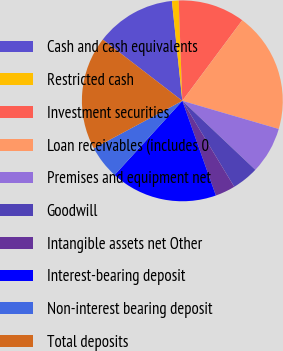Convert chart to OTSL. <chart><loc_0><loc_0><loc_500><loc_500><pie_chart><fcel>Cash and cash equivalents<fcel>Restricted cash<fcel>Investment securities<fcel>Loan receivables (includes 0<fcel>Premises and equipment net<fcel>Goodwill<fcel>Intangible assets net Other<fcel>Interest-bearing deposit<fcel>Non-interest bearing deposit<fcel>Total deposits<nl><fcel>12.9%<fcel>1.08%<fcel>10.75%<fcel>19.35%<fcel>7.53%<fcel>4.3%<fcel>3.23%<fcel>17.2%<fcel>5.38%<fcel>18.28%<nl></chart> 